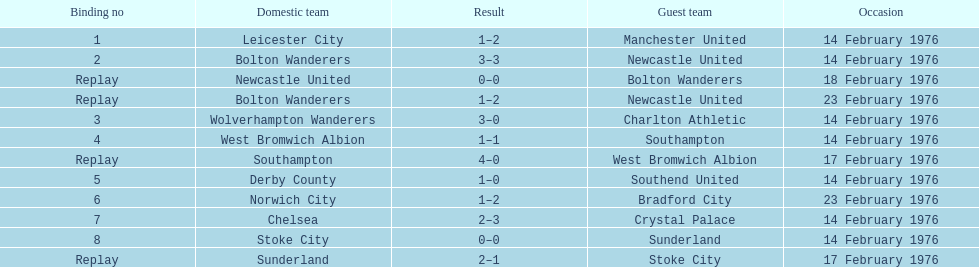Which teams played the same day as leicester city and manchester united? Bolton Wanderers, Newcastle United. 